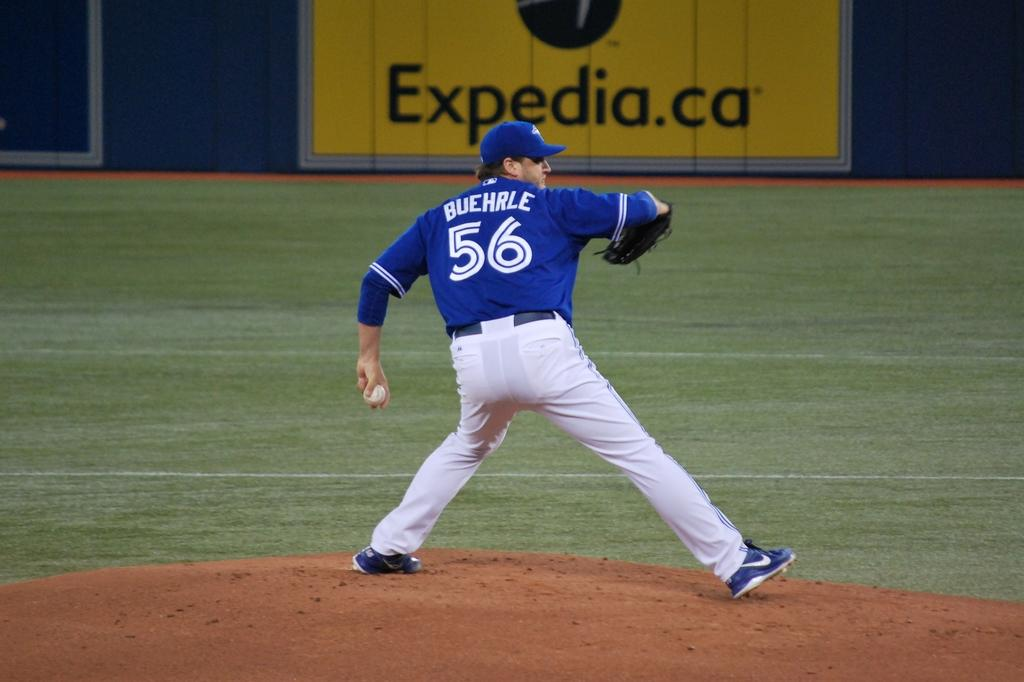<image>
Render a clear and concise summary of the photo. The baseball stadium in Canada has Expedia.ca as a sponsor. 